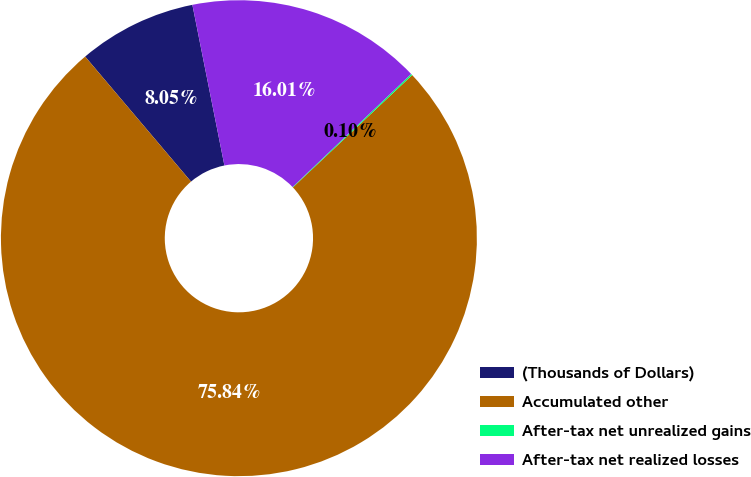Convert chart to OTSL. <chart><loc_0><loc_0><loc_500><loc_500><pie_chart><fcel>(Thousands of Dollars)<fcel>Accumulated other<fcel>After-tax net unrealized gains<fcel>After-tax net realized losses<nl><fcel>8.05%<fcel>75.84%<fcel>0.1%<fcel>16.01%<nl></chart> 